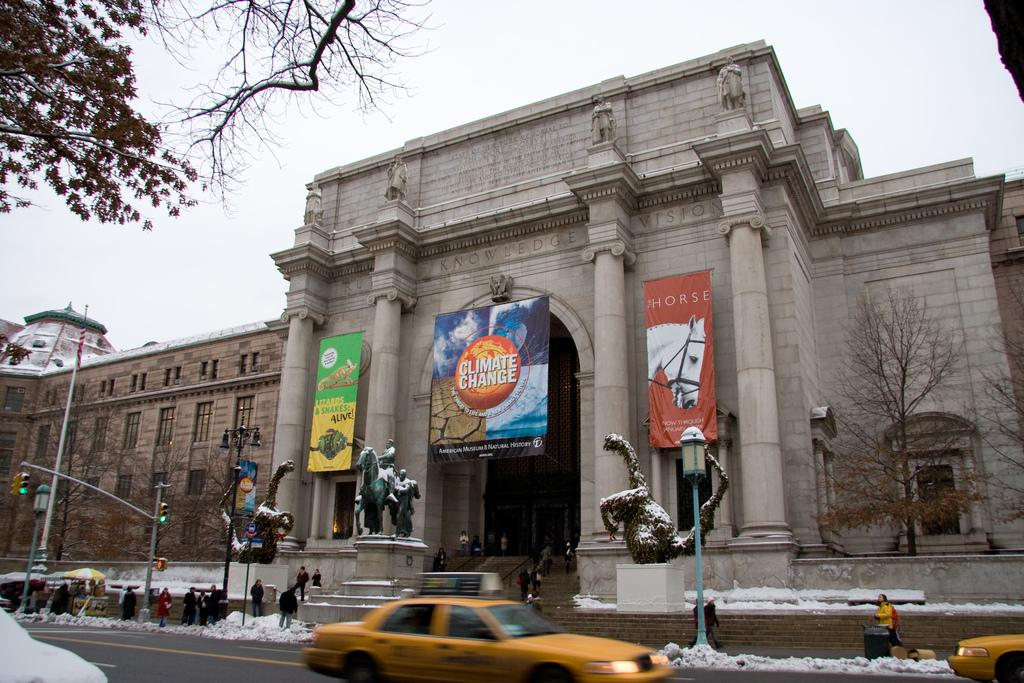<image>
Summarize the visual content of the image. A large building with taxis in front has a sign hanging that says Climate Change. 